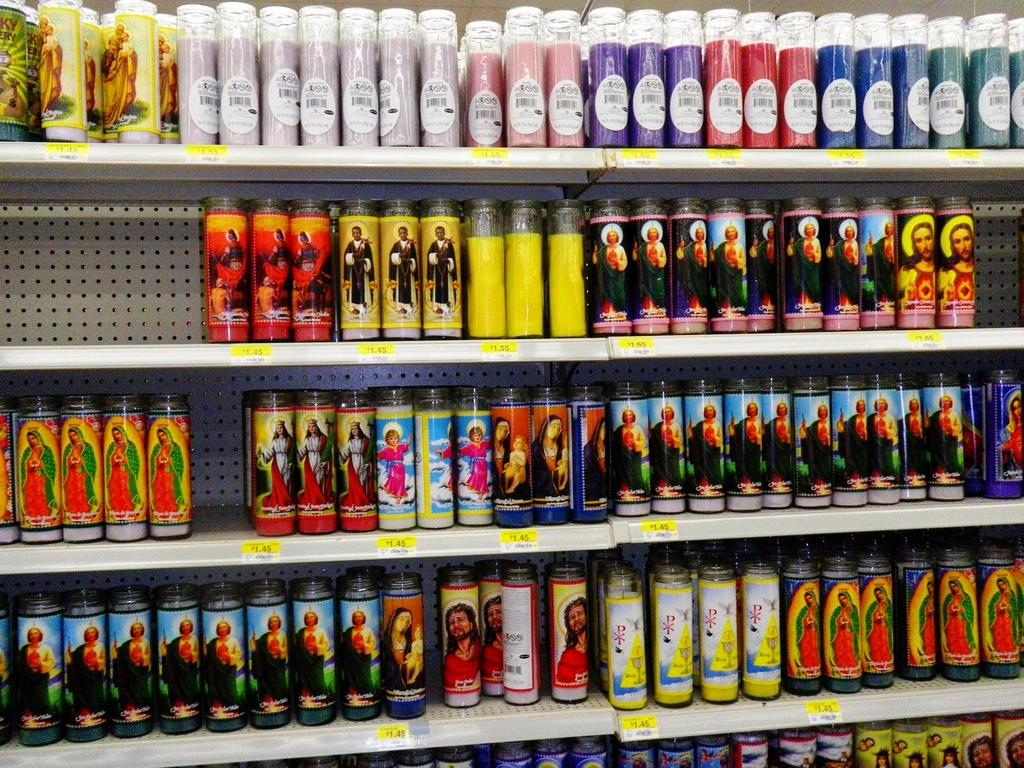What can be seen on the racks in the image? There are bottles on the racks in the image. What is unique about the bottles on the racks? The bottles have stickers and pictures on them. Are there any stickers on the racks themselves? Yes, there are stickers on the racks. What type of baseball is being cooked on the stove in the image? There is no baseball or stove present in the image. What is the price of the item being sold in the image? There is no item being sold in the image, so it is not possible to determine its price. 